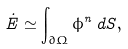Convert formula to latex. <formula><loc_0><loc_0><loc_500><loc_500>\dot { E } \simeq \int _ { \partial \Omega } \phi ^ { n } \, d S ,</formula> 